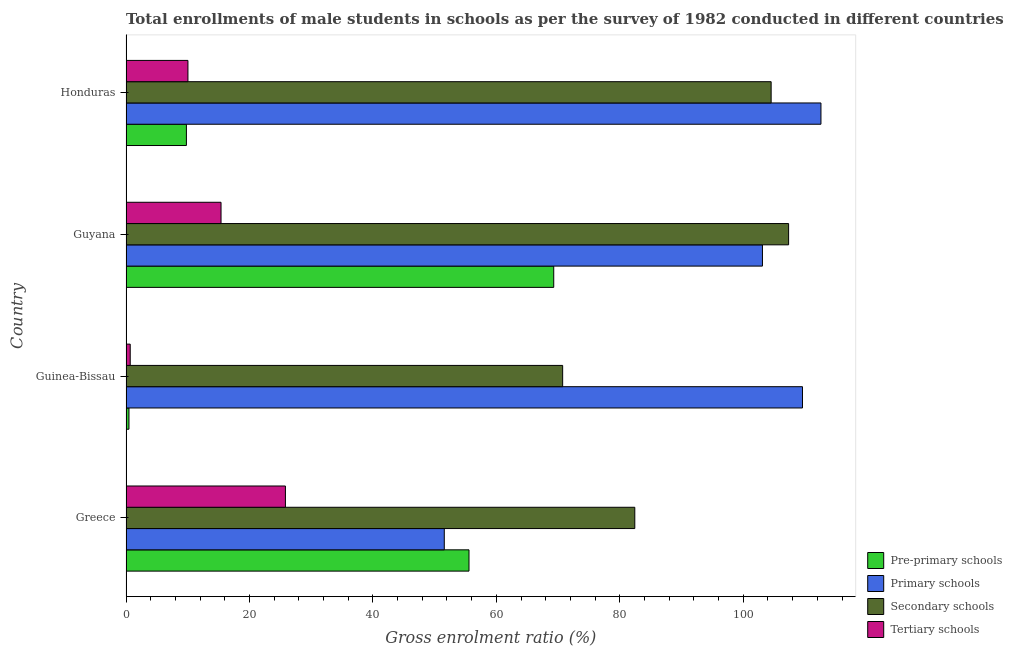How many groups of bars are there?
Ensure brevity in your answer.  4. How many bars are there on the 1st tick from the bottom?
Provide a short and direct response. 4. What is the label of the 4th group of bars from the top?
Ensure brevity in your answer.  Greece. What is the gross enrolment ratio(male) in tertiary schools in Greece?
Keep it short and to the point. 25.83. Across all countries, what is the maximum gross enrolment ratio(male) in pre-primary schools?
Ensure brevity in your answer.  69.3. Across all countries, what is the minimum gross enrolment ratio(male) in primary schools?
Keep it short and to the point. 51.56. In which country was the gross enrolment ratio(male) in pre-primary schools maximum?
Your response must be concise. Guyana. In which country was the gross enrolment ratio(male) in tertiary schools minimum?
Give a very brief answer. Guinea-Bissau. What is the total gross enrolment ratio(male) in tertiary schools in the graph?
Give a very brief answer. 51.94. What is the difference between the gross enrolment ratio(male) in pre-primary schools in Greece and that in Guyana?
Provide a short and direct response. -13.73. What is the difference between the gross enrolment ratio(male) in tertiary schools in Greece and the gross enrolment ratio(male) in primary schools in Guinea-Bissau?
Offer a very short reply. -83.77. What is the average gross enrolment ratio(male) in secondary schools per country?
Ensure brevity in your answer.  91.26. What is the difference between the gross enrolment ratio(male) in tertiary schools and gross enrolment ratio(male) in primary schools in Guinea-Bissau?
Your answer should be very brief. -108.91. In how many countries, is the gross enrolment ratio(male) in secondary schools greater than 12 %?
Provide a succinct answer. 4. What is the ratio of the gross enrolment ratio(male) in primary schools in Greece to that in Guyana?
Give a very brief answer. 0.5. Is the gross enrolment ratio(male) in primary schools in Greece less than that in Guinea-Bissau?
Offer a very short reply. Yes. What is the difference between the highest and the second highest gross enrolment ratio(male) in secondary schools?
Your answer should be compact. 2.83. What is the difference between the highest and the lowest gross enrolment ratio(male) in pre-primary schools?
Offer a very short reply. 68.82. What does the 3rd bar from the top in Guinea-Bissau represents?
Ensure brevity in your answer.  Primary schools. What does the 1st bar from the bottom in Guyana represents?
Ensure brevity in your answer.  Pre-primary schools. Is it the case that in every country, the sum of the gross enrolment ratio(male) in pre-primary schools and gross enrolment ratio(male) in primary schools is greater than the gross enrolment ratio(male) in secondary schools?
Provide a short and direct response. Yes. Are all the bars in the graph horizontal?
Ensure brevity in your answer.  Yes. Are the values on the major ticks of X-axis written in scientific E-notation?
Provide a succinct answer. No. Does the graph contain any zero values?
Provide a succinct answer. No. Does the graph contain grids?
Ensure brevity in your answer.  No. How are the legend labels stacked?
Provide a short and direct response. Vertical. What is the title of the graph?
Your answer should be compact. Total enrollments of male students in schools as per the survey of 1982 conducted in different countries. Does "Portugal" appear as one of the legend labels in the graph?
Ensure brevity in your answer.  No. What is the label or title of the Y-axis?
Your answer should be compact. Country. What is the Gross enrolment ratio (%) in Pre-primary schools in Greece?
Your response must be concise. 55.57. What is the Gross enrolment ratio (%) in Primary schools in Greece?
Provide a succinct answer. 51.56. What is the Gross enrolment ratio (%) in Secondary schools in Greece?
Keep it short and to the point. 82.43. What is the Gross enrolment ratio (%) of Tertiary schools in Greece?
Offer a terse response. 25.83. What is the Gross enrolment ratio (%) of Pre-primary schools in Guinea-Bissau?
Offer a very short reply. 0.48. What is the Gross enrolment ratio (%) of Primary schools in Guinea-Bissau?
Ensure brevity in your answer.  109.6. What is the Gross enrolment ratio (%) of Secondary schools in Guinea-Bissau?
Your response must be concise. 70.74. What is the Gross enrolment ratio (%) of Tertiary schools in Guinea-Bissau?
Your answer should be very brief. 0.68. What is the Gross enrolment ratio (%) in Pre-primary schools in Guyana?
Your response must be concise. 69.3. What is the Gross enrolment ratio (%) in Primary schools in Guyana?
Provide a short and direct response. 103.11. What is the Gross enrolment ratio (%) in Secondary schools in Guyana?
Provide a short and direct response. 107.35. What is the Gross enrolment ratio (%) of Tertiary schools in Guyana?
Offer a terse response. 15.39. What is the Gross enrolment ratio (%) in Pre-primary schools in Honduras?
Offer a terse response. 9.79. What is the Gross enrolment ratio (%) in Primary schools in Honduras?
Provide a succinct answer. 112.59. What is the Gross enrolment ratio (%) of Secondary schools in Honduras?
Your answer should be very brief. 104.52. What is the Gross enrolment ratio (%) of Tertiary schools in Honduras?
Keep it short and to the point. 10.03. Across all countries, what is the maximum Gross enrolment ratio (%) of Pre-primary schools?
Provide a short and direct response. 69.3. Across all countries, what is the maximum Gross enrolment ratio (%) in Primary schools?
Provide a succinct answer. 112.59. Across all countries, what is the maximum Gross enrolment ratio (%) of Secondary schools?
Your response must be concise. 107.35. Across all countries, what is the maximum Gross enrolment ratio (%) in Tertiary schools?
Your answer should be very brief. 25.83. Across all countries, what is the minimum Gross enrolment ratio (%) of Pre-primary schools?
Offer a very short reply. 0.48. Across all countries, what is the minimum Gross enrolment ratio (%) in Primary schools?
Your answer should be very brief. 51.56. Across all countries, what is the minimum Gross enrolment ratio (%) of Secondary schools?
Give a very brief answer. 70.74. Across all countries, what is the minimum Gross enrolment ratio (%) in Tertiary schools?
Offer a very short reply. 0.68. What is the total Gross enrolment ratio (%) of Pre-primary schools in the graph?
Give a very brief answer. 135.13. What is the total Gross enrolment ratio (%) in Primary schools in the graph?
Give a very brief answer. 376.85. What is the total Gross enrolment ratio (%) in Secondary schools in the graph?
Make the answer very short. 365.03. What is the total Gross enrolment ratio (%) in Tertiary schools in the graph?
Offer a very short reply. 51.94. What is the difference between the Gross enrolment ratio (%) in Pre-primary schools in Greece and that in Guinea-Bissau?
Offer a terse response. 55.09. What is the difference between the Gross enrolment ratio (%) in Primary schools in Greece and that in Guinea-Bissau?
Your answer should be very brief. -58.03. What is the difference between the Gross enrolment ratio (%) in Secondary schools in Greece and that in Guinea-Bissau?
Your answer should be very brief. 11.69. What is the difference between the Gross enrolment ratio (%) in Tertiary schools in Greece and that in Guinea-Bissau?
Give a very brief answer. 25.14. What is the difference between the Gross enrolment ratio (%) in Pre-primary schools in Greece and that in Guyana?
Offer a terse response. -13.73. What is the difference between the Gross enrolment ratio (%) in Primary schools in Greece and that in Guyana?
Provide a short and direct response. -51.55. What is the difference between the Gross enrolment ratio (%) in Secondary schools in Greece and that in Guyana?
Offer a very short reply. -24.92. What is the difference between the Gross enrolment ratio (%) in Tertiary schools in Greece and that in Guyana?
Provide a short and direct response. 10.43. What is the difference between the Gross enrolment ratio (%) in Pre-primary schools in Greece and that in Honduras?
Make the answer very short. 45.78. What is the difference between the Gross enrolment ratio (%) in Primary schools in Greece and that in Honduras?
Provide a short and direct response. -61.02. What is the difference between the Gross enrolment ratio (%) in Secondary schools in Greece and that in Honduras?
Provide a succinct answer. -22.09. What is the difference between the Gross enrolment ratio (%) in Tertiary schools in Greece and that in Honduras?
Keep it short and to the point. 15.79. What is the difference between the Gross enrolment ratio (%) in Pre-primary schools in Guinea-Bissau and that in Guyana?
Make the answer very short. -68.82. What is the difference between the Gross enrolment ratio (%) of Primary schools in Guinea-Bissau and that in Guyana?
Provide a succinct answer. 6.49. What is the difference between the Gross enrolment ratio (%) in Secondary schools in Guinea-Bissau and that in Guyana?
Your response must be concise. -36.61. What is the difference between the Gross enrolment ratio (%) of Tertiary schools in Guinea-Bissau and that in Guyana?
Offer a terse response. -14.71. What is the difference between the Gross enrolment ratio (%) of Pre-primary schools in Guinea-Bissau and that in Honduras?
Keep it short and to the point. -9.31. What is the difference between the Gross enrolment ratio (%) in Primary schools in Guinea-Bissau and that in Honduras?
Keep it short and to the point. -2.99. What is the difference between the Gross enrolment ratio (%) of Secondary schools in Guinea-Bissau and that in Honduras?
Make the answer very short. -33.78. What is the difference between the Gross enrolment ratio (%) of Tertiary schools in Guinea-Bissau and that in Honduras?
Give a very brief answer. -9.35. What is the difference between the Gross enrolment ratio (%) in Pre-primary schools in Guyana and that in Honduras?
Make the answer very short. 59.51. What is the difference between the Gross enrolment ratio (%) in Primary schools in Guyana and that in Honduras?
Your answer should be compact. -9.48. What is the difference between the Gross enrolment ratio (%) in Secondary schools in Guyana and that in Honduras?
Your answer should be very brief. 2.83. What is the difference between the Gross enrolment ratio (%) of Tertiary schools in Guyana and that in Honduras?
Provide a succinct answer. 5.36. What is the difference between the Gross enrolment ratio (%) of Pre-primary schools in Greece and the Gross enrolment ratio (%) of Primary schools in Guinea-Bissau?
Offer a very short reply. -54.03. What is the difference between the Gross enrolment ratio (%) of Pre-primary schools in Greece and the Gross enrolment ratio (%) of Secondary schools in Guinea-Bissau?
Offer a terse response. -15.17. What is the difference between the Gross enrolment ratio (%) in Pre-primary schools in Greece and the Gross enrolment ratio (%) in Tertiary schools in Guinea-Bissau?
Offer a terse response. 54.88. What is the difference between the Gross enrolment ratio (%) of Primary schools in Greece and the Gross enrolment ratio (%) of Secondary schools in Guinea-Bissau?
Offer a very short reply. -19.18. What is the difference between the Gross enrolment ratio (%) in Primary schools in Greece and the Gross enrolment ratio (%) in Tertiary schools in Guinea-Bissau?
Provide a succinct answer. 50.88. What is the difference between the Gross enrolment ratio (%) in Secondary schools in Greece and the Gross enrolment ratio (%) in Tertiary schools in Guinea-Bissau?
Give a very brief answer. 81.75. What is the difference between the Gross enrolment ratio (%) of Pre-primary schools in Greece and the Gross enrolment ratio (%) of Primary schools in Guyana?
Ensure brevity in your answer.  -47.54. What is the difference between the Gross enrolment ratio (%) of Pre-primary schools in Greece and the Gross enrolment ratio (%) of Secondary schools in Guyana?
Offer a terse response. -51.78. What is the difference between the Gross enrolment ratio (%) of Pre-primary schools in Greece and the Gross enrolment ratio (%) of Tertiary schools in Guyana?
Offer a terse response. 40.17. What is the difference between the Gross enrolment ratio (%) in Primary schools in Greece and the Gross enrolment ratio (%) in Secondary schools in Guyana?
Offer a very short reply. -55.78. What is the difference between the Gross enrolment ratio (%) in Primary schools in Greece and the Gross enrolment ratio (%) in Tertiary schools in Guyana?
Ensure brevity in your answer.  36.17. What is the difference between the Gross enrolment ratio (%) in Secondary schools in Greece and the Gross enrolment ratio (%) in Tertiary schools in Guyana?
Your answer should be very brief. 67.04. What is the difference between the Gross enrolment ratio (%) of Pre-primary schools in Greece and the Gross enrolment ratio (%) of Primary schools in Honduras?
Give a very brief answer. -57.02. What is the difference between the Gross enrolment ratio (%) in Pre-primary schools in Greece and the Gross enrolment ratio (%) in Secondary schools in Honduras?
Your answer should be compact. -48.95. What is the difference between the Gross enrolment ratio (%) in Pre-primary schools in Greece and the Gross enrolment ratio (%) in Tertiary schools in Honduras?
Provide a succinct answer. 45.53. What is the difference between the Gross enrolment ratio (%) in Primary schools in Greece and the Gross enrolment ratio (%) in Secondary schools in Honduras?
Ensure brevity in your answer.  -52.96. What is the difference between the Gross enrolment ratio (%) in Primary schools in Greece and the Gross enrolment ratio (%) in Tertiary schools in Honduras?
Ensure brevity in your answer.  41.53. What is the difference between the Gross enrolment ratio (%) of Secondary schools in Greece and the Gross enrolment ratio (%) of Tertiary schools in Honduras?
Your response must be concise. 72.4. What is the difference between the Gross enrolment ratio (%) of Pre-primary schools in Guinea-Bissau and the Gross enrolment ratio (%) of Primary schools in Guyana?
Your answer should be very brief. -102.63. What is the difference between the Gross enrolment ratio (%) of Pre-primary schools in Guinea-Bissau and the Gross enrolment ratio (%) of Secondary schools in Guyana?
Provide a succinct answer. -106.87. What is the difference between the Gross enrolment ratio (%) of Pre-primary schools in Guinea-Bissau and the Gross enrolment ratio (%) of Tertiary schools in Guyana?
Make the answer very short. -14.91. What is the difference between the Gross enrolment ratio (%) of Primary schools in Guinea-Bissau and the Gross enrolment ratio (%) of Secondary schools in Guyana?
Provide a succinct answer. 2.25. What is the difference between the Gross enrolment ratio (%) in Primary schools in Guinea-Bissau and the Gross enrolment ratio (%) in Tertiary schools in Guyana?
Your answer should be compact. 94.2. What is the difference between the Gross enrolment ratio (%) in Secondary schools in Guinea-Bissau and the Gross enrolment ratio (%) in Tertiary schools in Guyana?
Make the answer very short. 55.35. What is the difference between the Gross enrolment ratio (%) in Pre-primary schools in Guinea-Bissau and the Gross enrolment ratio (%) in Primary schools in Honduras?
Provide a succinct answer. -112.11. What is the difference between the Gross enrolment ratio (%) in Pre-primary schools in Guinea-Bissau and the Gross enrolment ratio (%) in Secondary schools in Honduras?
Give a very brief answer. -104.04. What is the difference between the Gross enrolment ratio (%) of Pre-primary schools in Guinea-Bissau and the Gross enrolment ratio (%) of Tertiary schools in Honduras?
Your response must be concise. -9.55. What is the difference between the Gross enrolment ratio (%) in Primary schools in Guinea-Bissau and the Gross enrolment ratio (%) in Secondary schools in Honduras?
Provide a short and direct response. 5.08. What is the difference between the Gross enrolment ratio (%) of Primary schools in Guinea-Bissau and the Gross enrolment ratio (%) of Tertiary schools in Honduras?
Offer a terse response. 99.56. What is the difference between the Gross enrolment ratio (%) of Secondary schools in Guinea-Bissau and the Gross enrolment ratio (%) of Tertiary schools in Honduras?
Give a very brief answer. 60.71. What is the difference between the Gross enrolment ratio (%) in Pre-primary schools in Guyana and the Gross enrolment ratio (%) in Primary schools in Honduras?
Provide a short and direct response. -43.29. What is the difference between the Gross enrolment ratio (%) of Pre-primary schools in Guyana and the Gross enrolment ratio (%) of Secondary schools in Honduras?
Ensure brevity in your answer.  -35.22. What is the difference between the Gross enrolment ratio (%) in Pre-primary schools in Guyana and the Gross enrolment ratio (%) in Tertiary schools in Honduras?
Ensure brevity in your answer.  59.26. What is the difference between the Gross enrolment ratio (%) of Primary schools in Guyana and the Gross enrolment ratio (%) of Secondary schools in Honduras?
Provide a succinct answer. -1.41. What is the difference between the Gross enrolment ratio (%) of Primary schools in Guyana and the Gross enrolment ratio (%) of Tertiary schools in Honduras?
Provide a succinct answer. 93.08. What is the difference between the Gross enrolment ratio (%) of Secondary schools in Guyana and the Gross enrolment ratio (%) of Tertiary schools in Honduras?
Give a very brief answer. 97.31. What is the average Gross enrolment ratio (%) of Pre-primary schools per country?
Ensure brevity in your answer.  33.78. What is the average Gross enrolment ratio (%) in Primary schools per country?
Provide a succinct answer. 94.21. What is the average Gross enrolment ratio (%) in Secondary schools per country?
Offer a terse response. 91.26. What is the average Gross enrolment ratio (%) in Tertiary schools per country?
Offer a terse response. 12.98. What is the difference between the Gross enrolment ratio (%) of Pre-primary schools and Gross enrolment ratio (%) of Primary schools in Greece?
Offer a very short reply. 4. What is the difference between the Gross enrolment ratio (%) in Pre-primary schools and Gross enrolment ratio (%) in Secondary schools in Greece?
Offer a terse response. -26.86. What is the difference between the Gross enrolment ratio (%) in Pre-primary schools and Gross enrolment ratio (%) in Tertiary schools in Greece?
Offer a terse response. 29.74. What is the difference between the Gross enrolment ratio (%) of Primary schools and Gross enrolment ratio (%) of Secondary schools in Greece?
Keep it short and to the point. -30.87. What is the difference between the Gross enrolment ratio (%) of Primary schools and Gross enrolment ratio (%) of Tertiary schools in Greece?
Keep it short and to the point. 25.74. What is the difference between the Gross enrolment ratio (%) in Secondary schools and Gross enrolment ratio (%) in Tertiary schools in Greece?
Make the answer very short. 56.6. What is the difference between the Gross enrolment ratio (%) of Pre-primary schools and Gross enrolment ratio (%) of Primary schools in Guinea-Bissau?
Your answer should be very brief. -109.12. What is the difference between the Gross enrolment ratio (%) of Pre-primary schools and Gross enrolment ratio (%) of Secondary schools in Guinea-Bissau?
Provide a short and direct response. -70.26. What is the difference between the Gross enrolment ratio (%) of Pre-primary schools and Gross enrolment ratio (%) of Tertiary schools in Guinea-Bissau?
Offer a terse response. -0.2. What is the difference between the Gross enrolment ratio (%) of Primary schools and Gross enrolment ratio (%) of Secondary schools in Guinea-Bissau?
Your answer should be compact. 38.86. What is the difference between the Gross enrolment ratio (%) in Primary schools and Gross enrolment ratio (%) in Tertiary schools in Guinea-Bissau?
Keep it short and to the point. 108.91. What is the difference between the Gross enrolment ratio (%) of Secondary schools and Gross enrolment ratio (%) of Tertiary schools in Guinea-Bissau?
Keep it short and to the point. 70.06. What is the difference between the Gross enrolment ratio (%) of Pre-primary schools and Gross enrolment ratio (%) of Primary schools in Guyana?
Ensure brevity in your answer.  -33.81. What is the difference between the Gross enrolment ratio (%) in Pre-primary schools and Gross enrolment ratio (%) in Secondary schools in Guyana?
Your answer should be very brief. -38.05. What is the difference between the Gross enrolment ratio (%) of Pre-primary schools and Gross enrolment ratio (%) of Tertiary schools in Guyana?
Your response must be concise. 53.9. What is the difference between the Gross enrolment ratio (%) of Primary schools and Gross enrolment ratio (%) of Secondary schools in Guyana?
Provide a short and direct response. -4.24. What is the difference between the Gross enrolment ratio (%) of Primary schools and Gross enrolment ratio (%) of Tertiary schools in Guyana?
Give a very brief answer. 87.72. What is the difference between the Gross enrolment ratio (%) in Secondary schools and Gross enrolment ratio (%) in Tertiary schools in Guyana?
Keep it short and to the point. 91.95. What is the difference between the Gross enrolment ratio (%) of Pre-primary schools and Gross enrolment ratio (%) of Primary schools in Honduras?
Your answer should be very brief. -102.8. What is the difference between the Gross enrolment ratio (%) in Pre-primary schools and Gross enrolment ratio (%) in Secondary schools in Honduras?
Offer a terse response. -94.73. What is the difference between the Gross enrolment ratio (%) in Pre-primary schools and Gross enrolment ratio (%) in Tertiary schools in Honduras?
Keep it short and to the point. -0.25. What is the difference between the Gross enrolment ratio (%) in Primary schools and Gross enrolment ratio (%) in Secondary schools in Honduras?
Your answer should be very brief. 8.07. What is the difference between the Gross enrolment ratio (%) in Primary schools and Gross enrolment ratio (%) in Tertiary schools in Honduras?
Keep it short and to the point. 102.55. What is the difference between the Gross enrolment ratio (%) of Secondary schools and Gross enrolment ratio (%) of Tertiary schools in Honduras?
Provide a short and direct response. 94.48. What is the ratio of the Gross enrolment ratio (%) in Pre-primary schools in Greece to that in Guinea-Bissau?
Provide a short and direct response. 116.08. What is the ratio of the Gross enrolment ratio (%) in Primary schools in Greece to that in Guinea-Bissau?
Keep it short and to the point. 0.47. What is the ratio of the Gross enrolment ratio (%) in Secondary schools in Greece to that in Guinea-Bissau?
Offer a terse response. 1.17. What is the ratio of the Gross enrolment ratio (%) of Tertiary schools in Greece to that in Guinea-Bissau?
Your response must be concise. 37.83. What is the ratio of the Gross enrolment ratio (%) of Pre-primary schools in Greece to that in Guyana?
Provide a short and direct response. 0.8. What is the ratio of the Gross enrolment ratio (%) in Primary schools in Greece to that in Guyana?
Make the answer very short. 0.5. What is the ratio of the Gross enrolment ratio (%) of Secondary schools in Greece to that in Guyana?
Make the answer very short. 0.77. What is the ratio of the Gross enrolment ratio (%) in Tertiary schools in Greece to that in Guyana?
Your answer should be very brief. 1.68. What is the ratio of the Gross enrolment ratio (%) in Pre-primary schools in Greece to that in Honduras?
Your response must be concise. 5.68. What is the ratio of the Gross enrolment ratio (%) in Primary schools in Greece to that in Honduras?
Provide a succinct answer. 0.46. What is the ratio of the Gross enrolment ratio (%) of Secondary schools in Greece to that in Honduras?
Give a very brief answer. 0.79. What is the ratio of the Gross enrolment ratio (%) in Tertiary schools in Greece to that in Honduras?
Offer a terse response. 2.57. What is the ratio of the Gross enrolment ratio (%) of Pre-primary schools in Guinea-Bissau to that in Guyana?
Offer a terse response. 0.01. What is the ratio of the Gross enrolment ratio (%) in Primary schools in Guinea-Bissau to that in Guyana?
Make the answer very short. 1.06. What is the ratio of the Gross enrolment ratio (%) in Secondary schools in Guinea-Bissau to that in Guyana?
Provide a succinct answer. 0.66. What is the ratio of the Gross enrolment ratio (%) of Tertiary schools in Guinea-Bissau to that in Guyana?
Offer a very short reply. 0.04. What is the ratio of the Gross enrolment ratio (%) of Pre-primary schools in Guinea-Bissau to that in Honduras?
Your answer should be compact. 0.05. What is the ratio of the Gross enrolment ratio (%) in Primary schools in Guinea-Bissau to that in Honduras?
Your answer should be compact. 0.97. What is the ratio of the Gross enrolment ratio (%) in Secondary schools in Guinea-Bissau to that in Honduras?
Offer a very short reply. 0.68. What is the ratio of the Gross enrolment ratio (%) in Tertiary schools in Guinea-Bissau to that in Honduras?
Give a very brief answer. 0.07. What is the ratio of the Gross enrolment ratio (%) of Pre-primary schools in Guyana to that in Honduras?
Provide a short and direct response. 7.08. What is the ratio of the Gross enrolment ratio (%) of Primary schools in Guyana to that in Honduras?
Your response must be concise. 0.92. What is the ratio of the Gross enrolment ratio (%) of Secondary schools in Guyana to that in Honduras?
Give a very brief answer. 1.03. What is the ratio of the Gross enrolment ratio (%) of Tertiary schools in Guyana to that in Honduras?
Keep it short and to the point. 1.53. What is the difference between the highest and the second highest Gross enrolment ratio (%) of Pre-primary schools?
Make the answer very short. 13.73. What is the difference between the highest and the second highest Gross enrolment ratio (%) of Primary schools?
Make the answer very short. 2.99. What is the difference between the highest and the second highest Gross enrolment ratio (%) in Secondary schools?
Your answer should be compact. 2.83. What is the difference between the highest and the second highest Gross enrolment ratio (%) in Tertiary schools?
Give a very brief answer. 10.43. What is the difference between the highest and the lowest Gross enrolment ratio (%) of Pre-primary schools?
Your answer should be compact. 68.82. What is the difference between the highest and the lowest Gross enrolment ratio (%) in Primary schools?
Your answer should be very brief. 61.02. What is the difference between the highest and the lowest Gross enrolment ratio (%) of Secondary schools?
Make the answer very short. 36.61. What is the difference between the highest and the lowest Gross enrolment ratio (%) of Tertiary schools?
Offer a terse response. 25.14. 